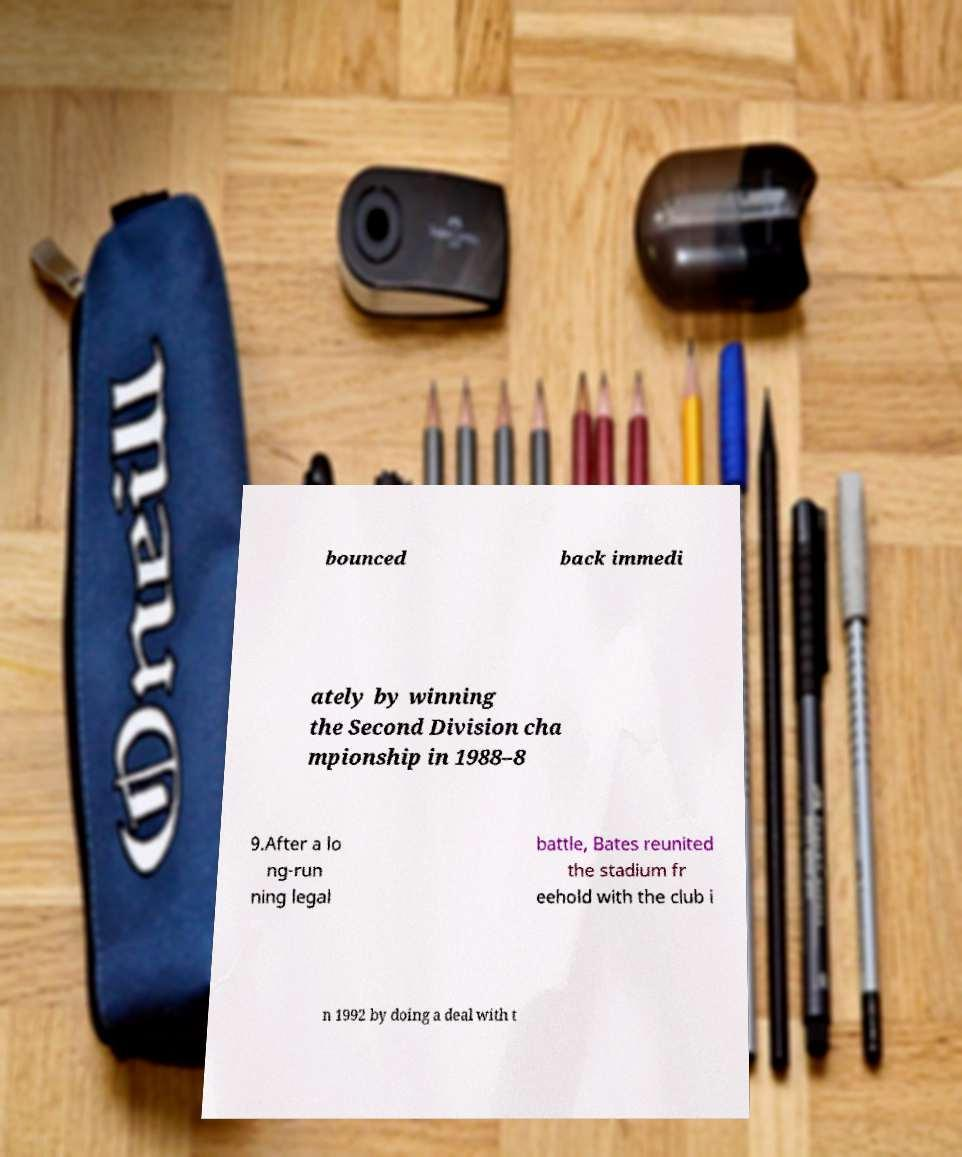Can you accurately transcribe the text from the provided image for me? bounced back immedi ately by winning the Second Division cha mpionship in 1988–8 9.After a lo ng-run ning legal battle, Bates reunited the stadium fr eehold with the club i n 1992 by doing a deal with t 